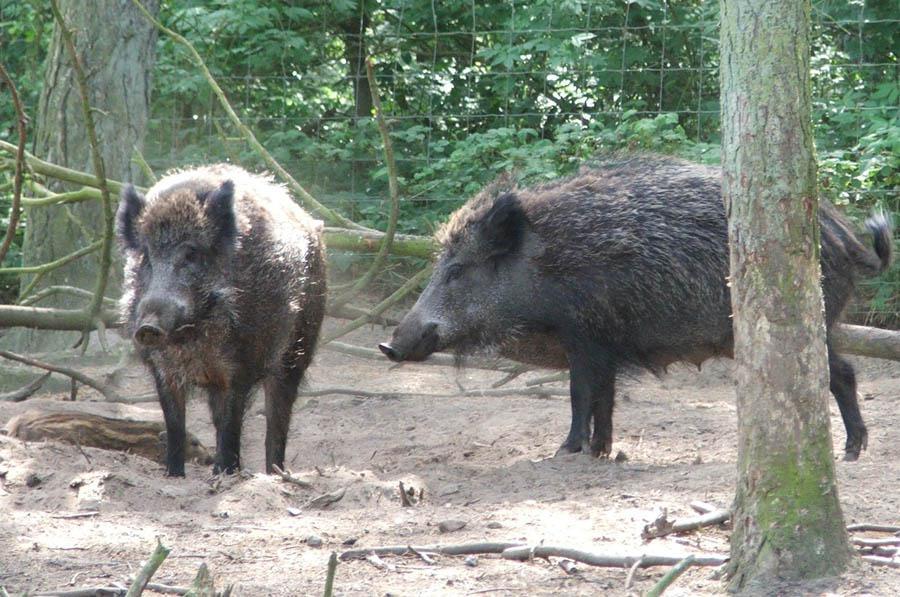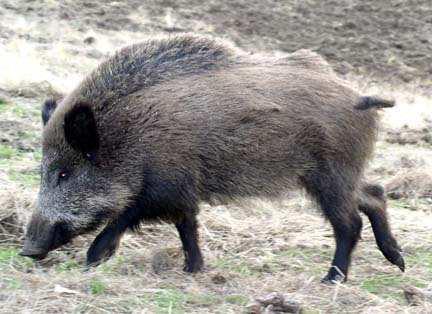The first image is the image on the left, the second image is the image on the right. Given the left and right images, does the statement "The hogs in the pair of images face opposite directions." hold true? Answer yes or no. No. 